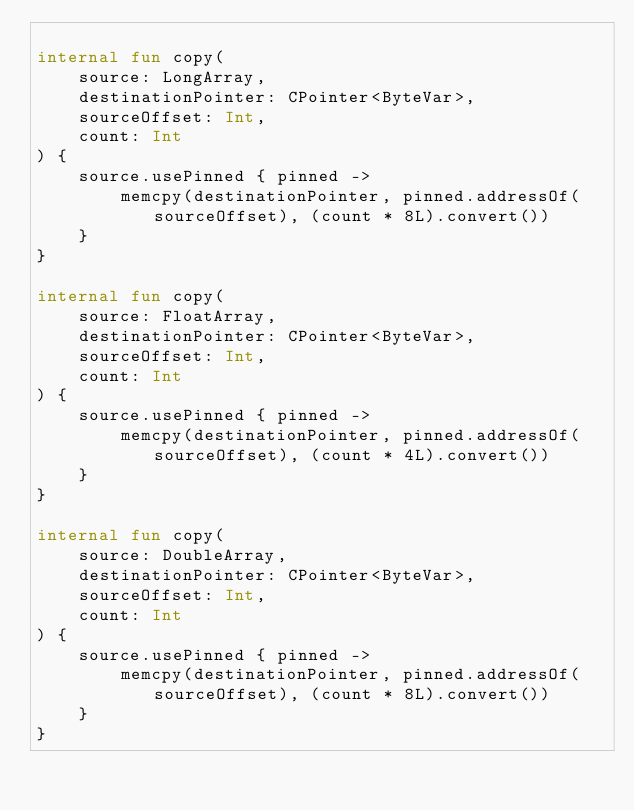<code> <loc_0><loc_0><loc_500><loc_500><_Kotlin_>
internal fun copy(
    source: LongArray,
    destinationPointer: CPointer<ByteVar>,
    sourceOffset: Int,
    count: Int
) {
    source.usePinned { pinned ->
        memcpy(destinationPointer, pinned.addressOf(sourceOffset), (count * 8L).convert())
    }
}

internal fun copy(
    source: FloatArray,
    destinationPointer: CPointer<ByteVar>,
    sourceOffset: Int,
    count: Int
) {
    source.usePinned { pinned ->
        memcpy(destinationPointer, pinned.addressOf(sourceOffset), (count * 4L).convert())
    }
}

internal fun copy(
    source: DoubleArray,
    destinationPointer: CPointer<ByteVar>,
    sourceOffset: Int,
    count: Int
) {
    source.usePinned { pinned ->
        memcpy(destinationPointer, pinned.addressOf(sourceOffset), (count * 8L).convert())
    }
}

</code> 